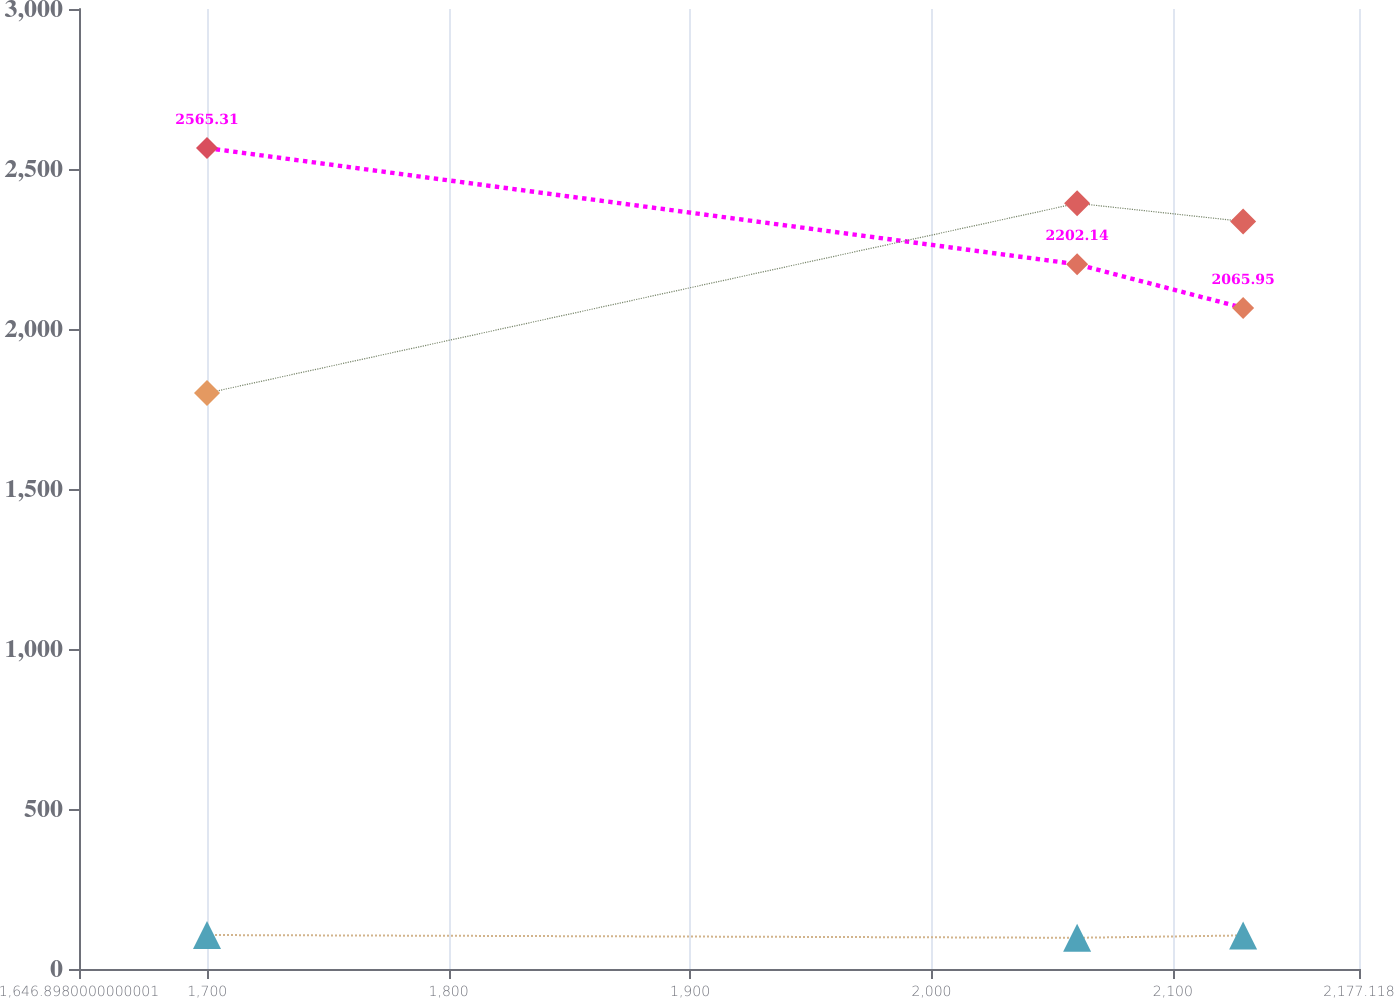Convert chart. <chart><loc_0><loc_0><loc_500><loc_500><line_chart><ecel><fcel>Average Monthly  Rent Per Unit<fcel>Number of  Units<fcel>Occupancy Rate<nl><fcel>1699.92<fcel>2565.31<fcel>106.17<fcel>1799.63<nl><fcel>2060.35<fcel>2202.14<fcel>97.57<fcel>2392.71<nl><fcel>2129.12<fcel>2065.95<fcel>104.84<fcel>2336.2<nl><fcel>2179.63<fcel>2285.15<fcel>109.88<fcel>2449.22<nl><fcel>2230.14<fcel>1938.02<fcel>111.21<fcel>2163.36<nl></chart> 